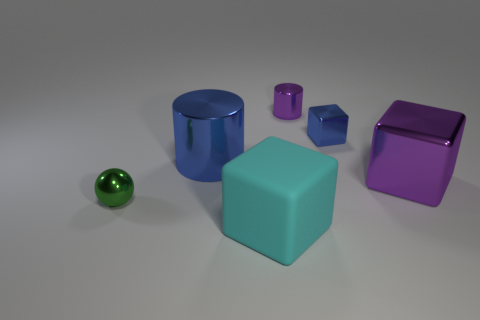Can you tell me about the different shapes present in this image? Certainly. In this image, we can see a variety of geometric shapes, including cylinders, cubes, and a sphere. The objects vary not only in shape but also in color, creating a visually engaging assortment. Which object stands out the most, and why? The bright green sphere stands out due to its distinct color, which contrasts with the other colors in the image, and its unique shape amidst a collection of angular, block-like structures. 